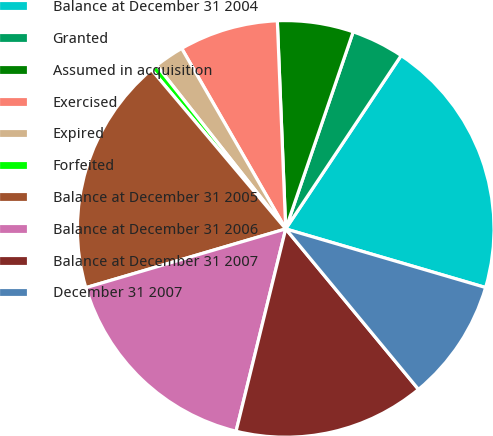Convert chart. <chart><loc_0><loc_0><loc_500><loc_500><pie_chart><fcel>Balance at December 31 2004<fcel>Granted<fcel>Assumed in acquisition<fcel>Exercised<fcel>Expired<fcel>Forfeited<fcel>Balance at December 31 2005<fcel>Balance at December 31 2006<fcel>Balance at December 31 2007<fcel>December 31 2007<nl><fcel>20.19%<fcel>4.1%<fcel>5.89%<fcel>7.68%<fcel>2.31%<fcel>0.52%<fcel>18.4%<fcel>16.62%<fcel>14.83%<fcel>9.46%<nl></chart> 